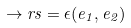Convert formula to latex. <formula><loc_0><loc_0><loc_500><loc_500>\to r s = \epsilon ( e _ { 1 } , e _ { 2 } )</formula> 